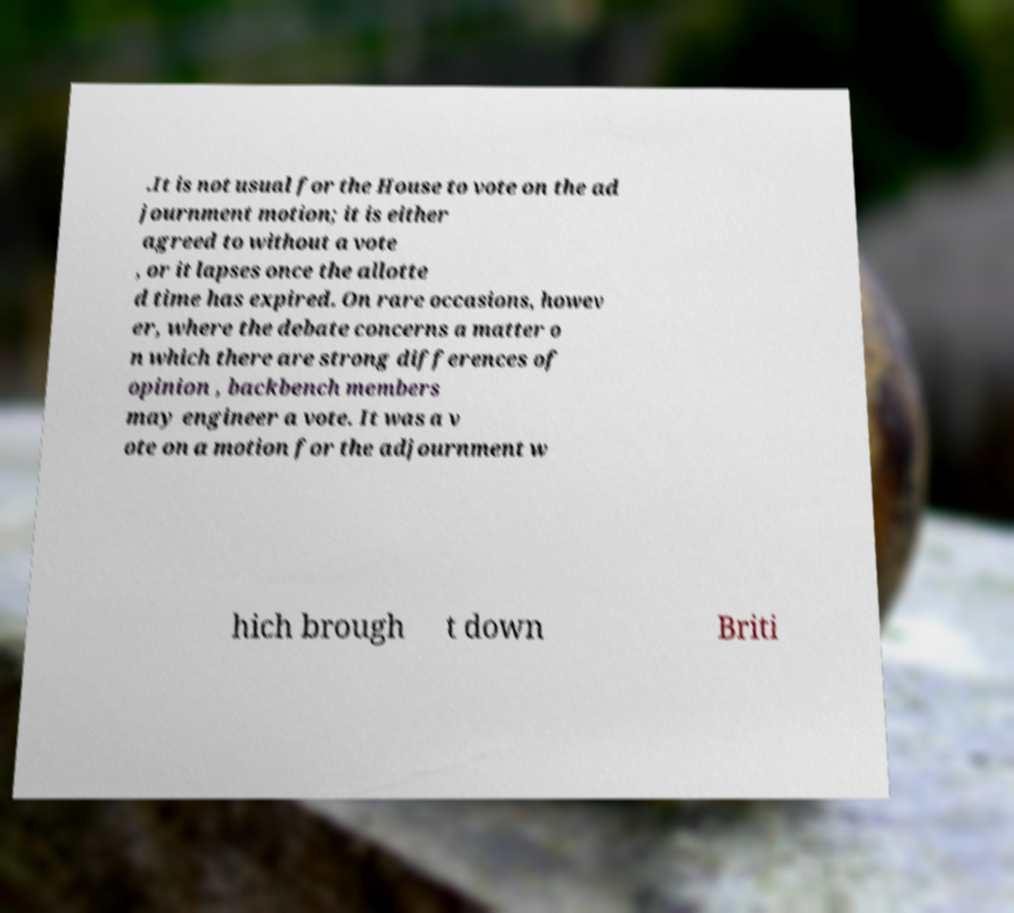What messages or text are displayed in this image? I need them in a readable, typed format. .It is not usual for the House to vote on the ad journment motion; it is either agreed to without a vote , or it lapses once the allotte d time has expired. On rare occasions, howev er, where the debate concerns a matter o n which there are strong differences of opinion , backbench members may engineer a vote. It was a v ote on a motion for the adjournment w hich brough t down Briti 